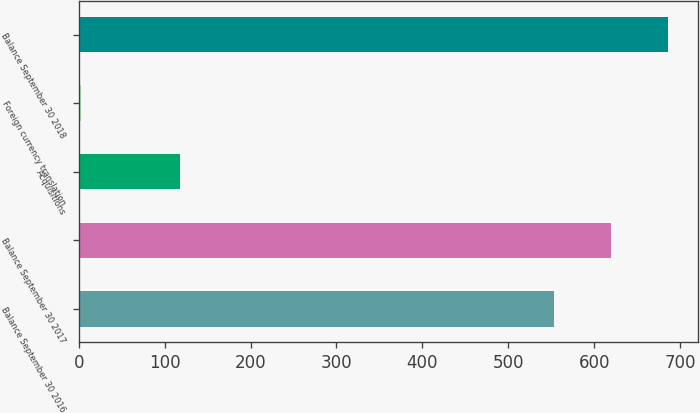Convert chart to OTSL. <chart><loc_0><loc_0><loc_500><loc_500><bar_chart><fcel>Balance September 30 2016<fcel>Balance September 30 2017<fcel>Acquisitions<fcel>Foreign currency translation<fcel>Balance September 30 2018<nl><fcel>553<fcel>619.7<fcel>118<fcel>3<fcel>686.4<nl></chart> 